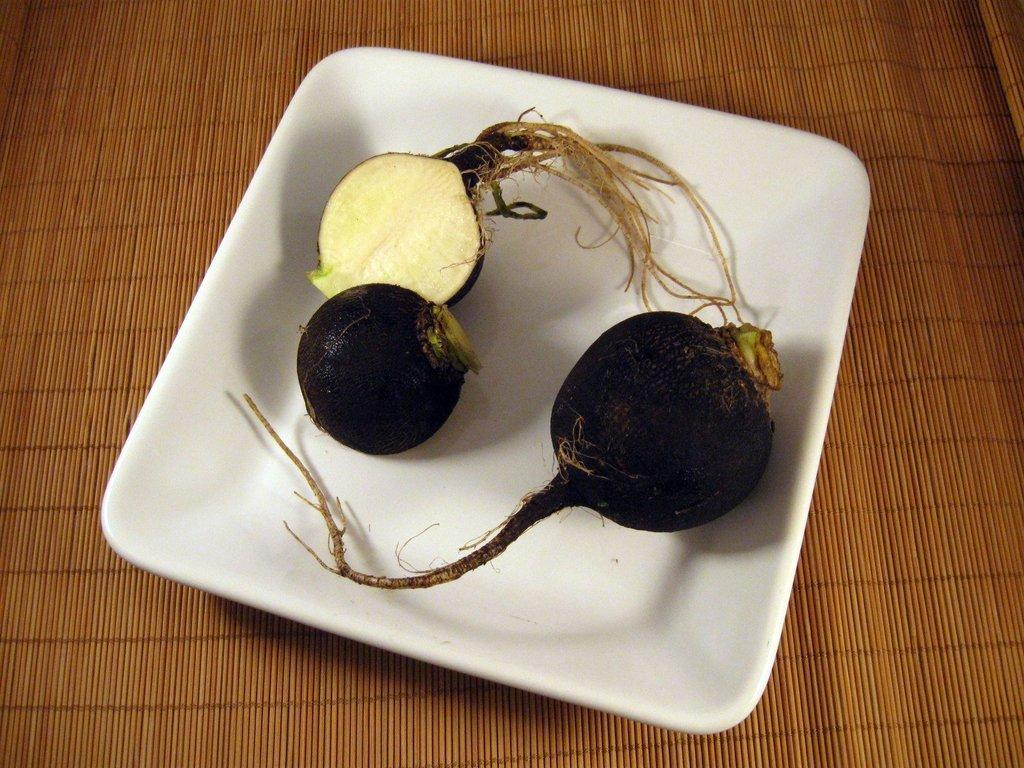What piece of furniture is visible in the image? There is a table in the image. What is placed on the table? There is a plate on the table. What type of food is on the plate? There are fruits on the plate. What news is being discussed by the fruits on the plate? There is no news being discussed in the image, as it only features a table, a plate, and fruits. 